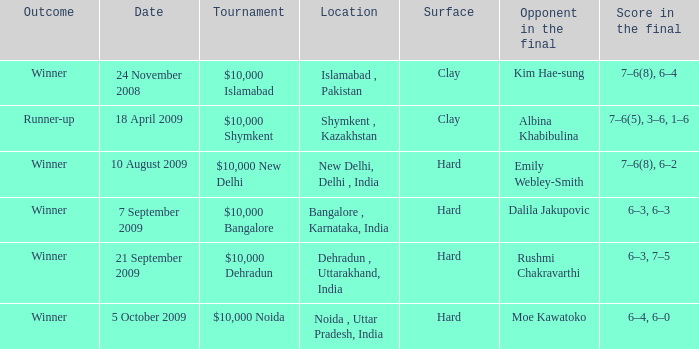What is the material of the surface in the dehradun , uttarakhand, india location Hard. 